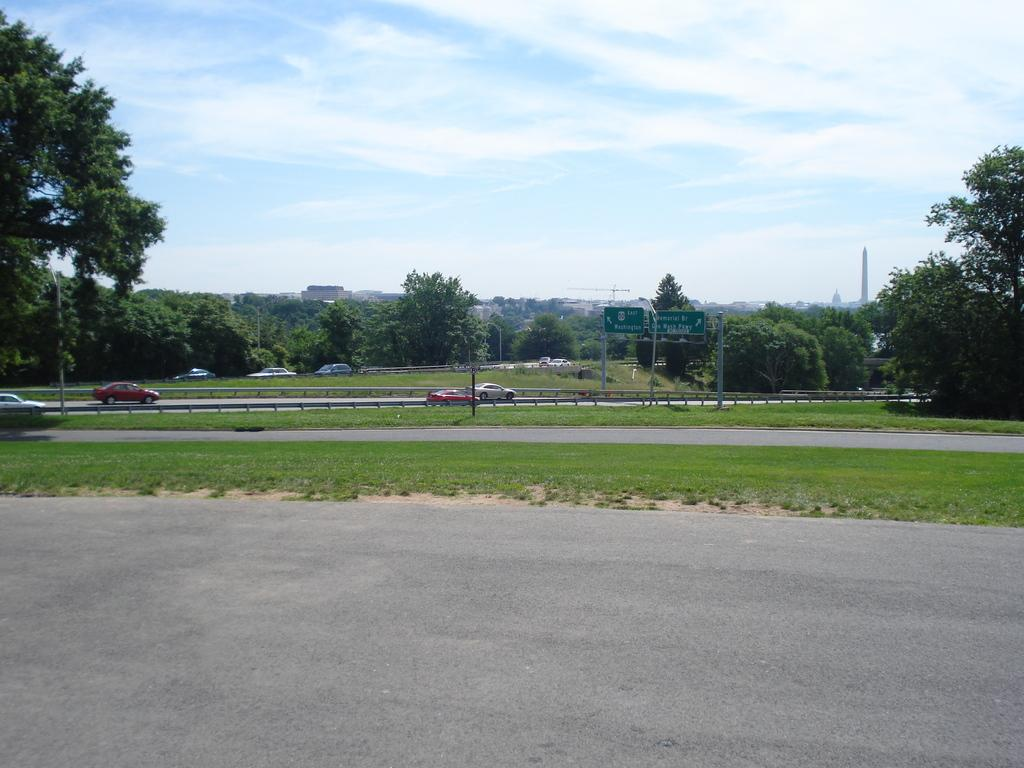What can be seen in the sky in the image? The sky is visible in the image. What type of natural vegetation is present in the image? There are trees in the image. What type of man-made structure is present in the image? There is a road in the image. What mode of transportation can be seen in the image? A vehicle is present in the image. What type of vertical structures are present in the image? There are poles in the image. Where was the image taken from? The image is taken from outside of the city. What type of basket is hanging from the trees in the image? There is no basket hanging from the trees in the image; only trees, a road, a vehicle, poles, and the sky are present. What type of bean is growing on the side of the road in the image? There is no bean growing on the side of the road in the image; only trees, a road, a vehicle, poles, and the sky are present. 